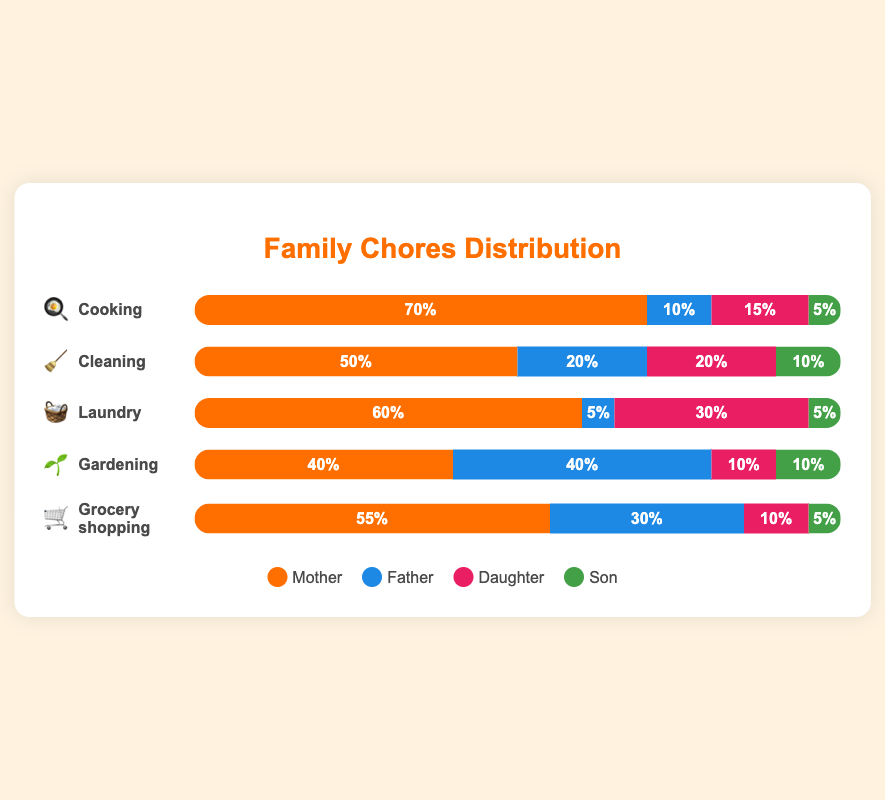Which family member does the most cooking? 🍳 The chart shows different colored bars representing each family member's contribution to cooking. The longest bar for "Cooking" belongs to the Mother, indicating she does the most cooking.
Answer: Mother Who has the smallest share of cleaning tasks? 🧹 For the "Cleaning" section, the bar with the smallest percentage is for the Son, which is 10%.
Answer: Son How does the distribution of laundry tasks differ from cooking tasks? 🧺 vs 🍳 For cooking, the distribution is 70% Mother, 10% Father, 15% Daughter, and 5% Son. For laundry, it's 60% Mother, 5% Father, 30% Daughter, and 5% Son. Notably, the Daughter takes on significantly more of the laundry tasks compared to cooking.
Answer: Mother does the most for both, Daughter does more laundry What percentage of gardening does the Father contribute? 🌱 Looking at the "Gardening" section of the chart, the bar for the Father shows he contributes 40%.
Answer: 40% Comparing grocery shopping and cleaning, which task does the Father contribute more to and by how much? 🛒 vs 🧹 For grocery shopping, the Father contributes 30%. For cleaning, it's 20%. So, the Father contributes 10% more to grocery shopping than cleaning.
Answer: Grocery shopping by 10% Who contributes more to household chores overall, Daughter or Son? To find out, sum up the contributions across all tasks for both Daughter and Son. For Daughter: 15% (cooking) + 20% (cleaning) + 30% (laundry) + 10% (gardening) + 10% (shopping) = 85%. For Son: 5% (cooking) + 10% (cleaning) + 5% (laundry) + 10% (gardening) + 5% (shopping) = 35%. Thus, the Daughter contributes more overall.
Answer: Daughter What is the combined percentage of gardening tasks handled by the Mother and Son? 🌱 The Mother's contribution to gardening is 40%, and the Son's is 10%. Adding these together, 40% + 10% equals a combined 50%.
Answer: 50% Who does the least amount of grocery shopping? 🛒 In the "Grocery shopping" section, the smallest percentage is for the Son, which is 5%.
Answer: Son Does the Mother have over 50% contribution in more than one task? If so, which tasks? The Mother contributes over 50% in "Cooking" (70%), "Laundry" (60%), and "Grocery shopping" (55%), making it more than one task.
Answer: Yes, Cooking, Laundry, Grocery shopping 